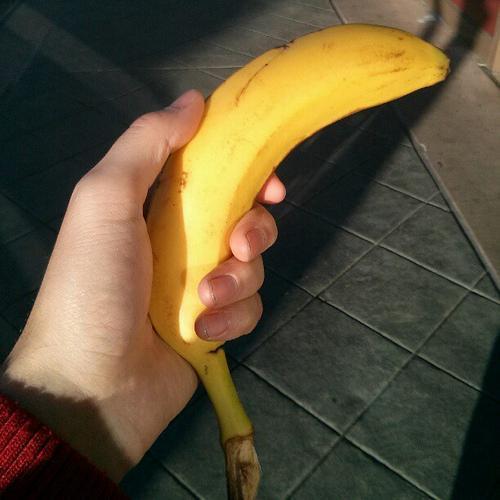How many bananas are there?
Give a very brief answer. 1. How many fingers are shown?
Give a very brief answer. 5. 